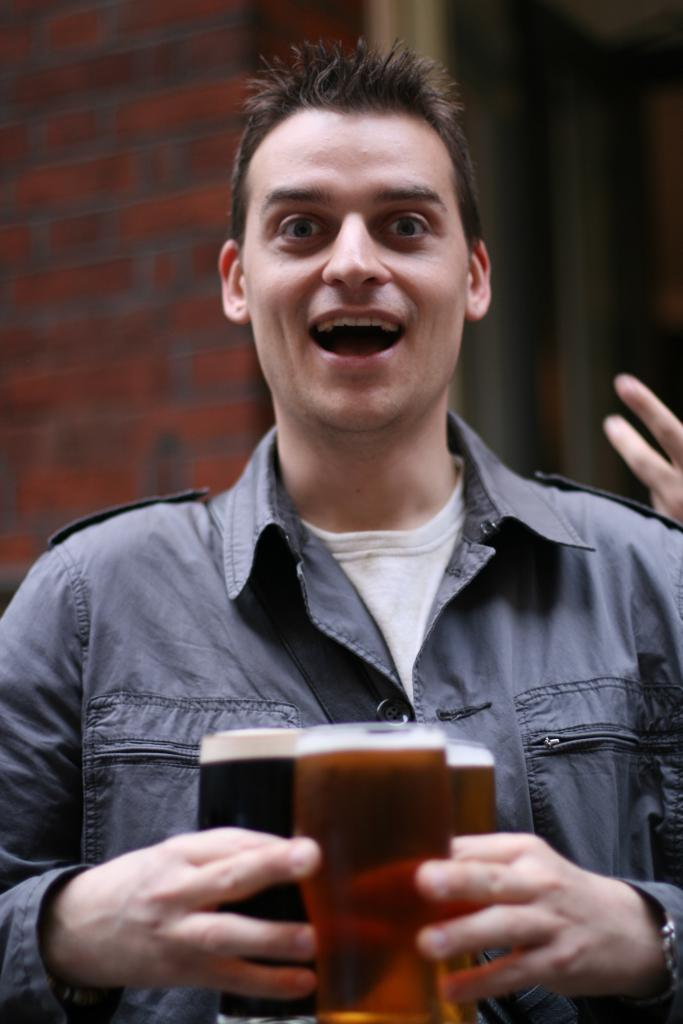What is the main subject of the image? The main subject of the image is a man standing in the middle. What is the man holding in the image? The man is holding beer glasses. What is the man's facial expression in the image? The man is smiling. What can be seen behind the man in the image? There is a brick wall behind the man. What type of zipper can be seen on the man's clothing in the image? There is no zipper visible on the man's clothing in the image. What letters are written on the brick wall behind the man? There are no letters written on the brick wall in the image. 